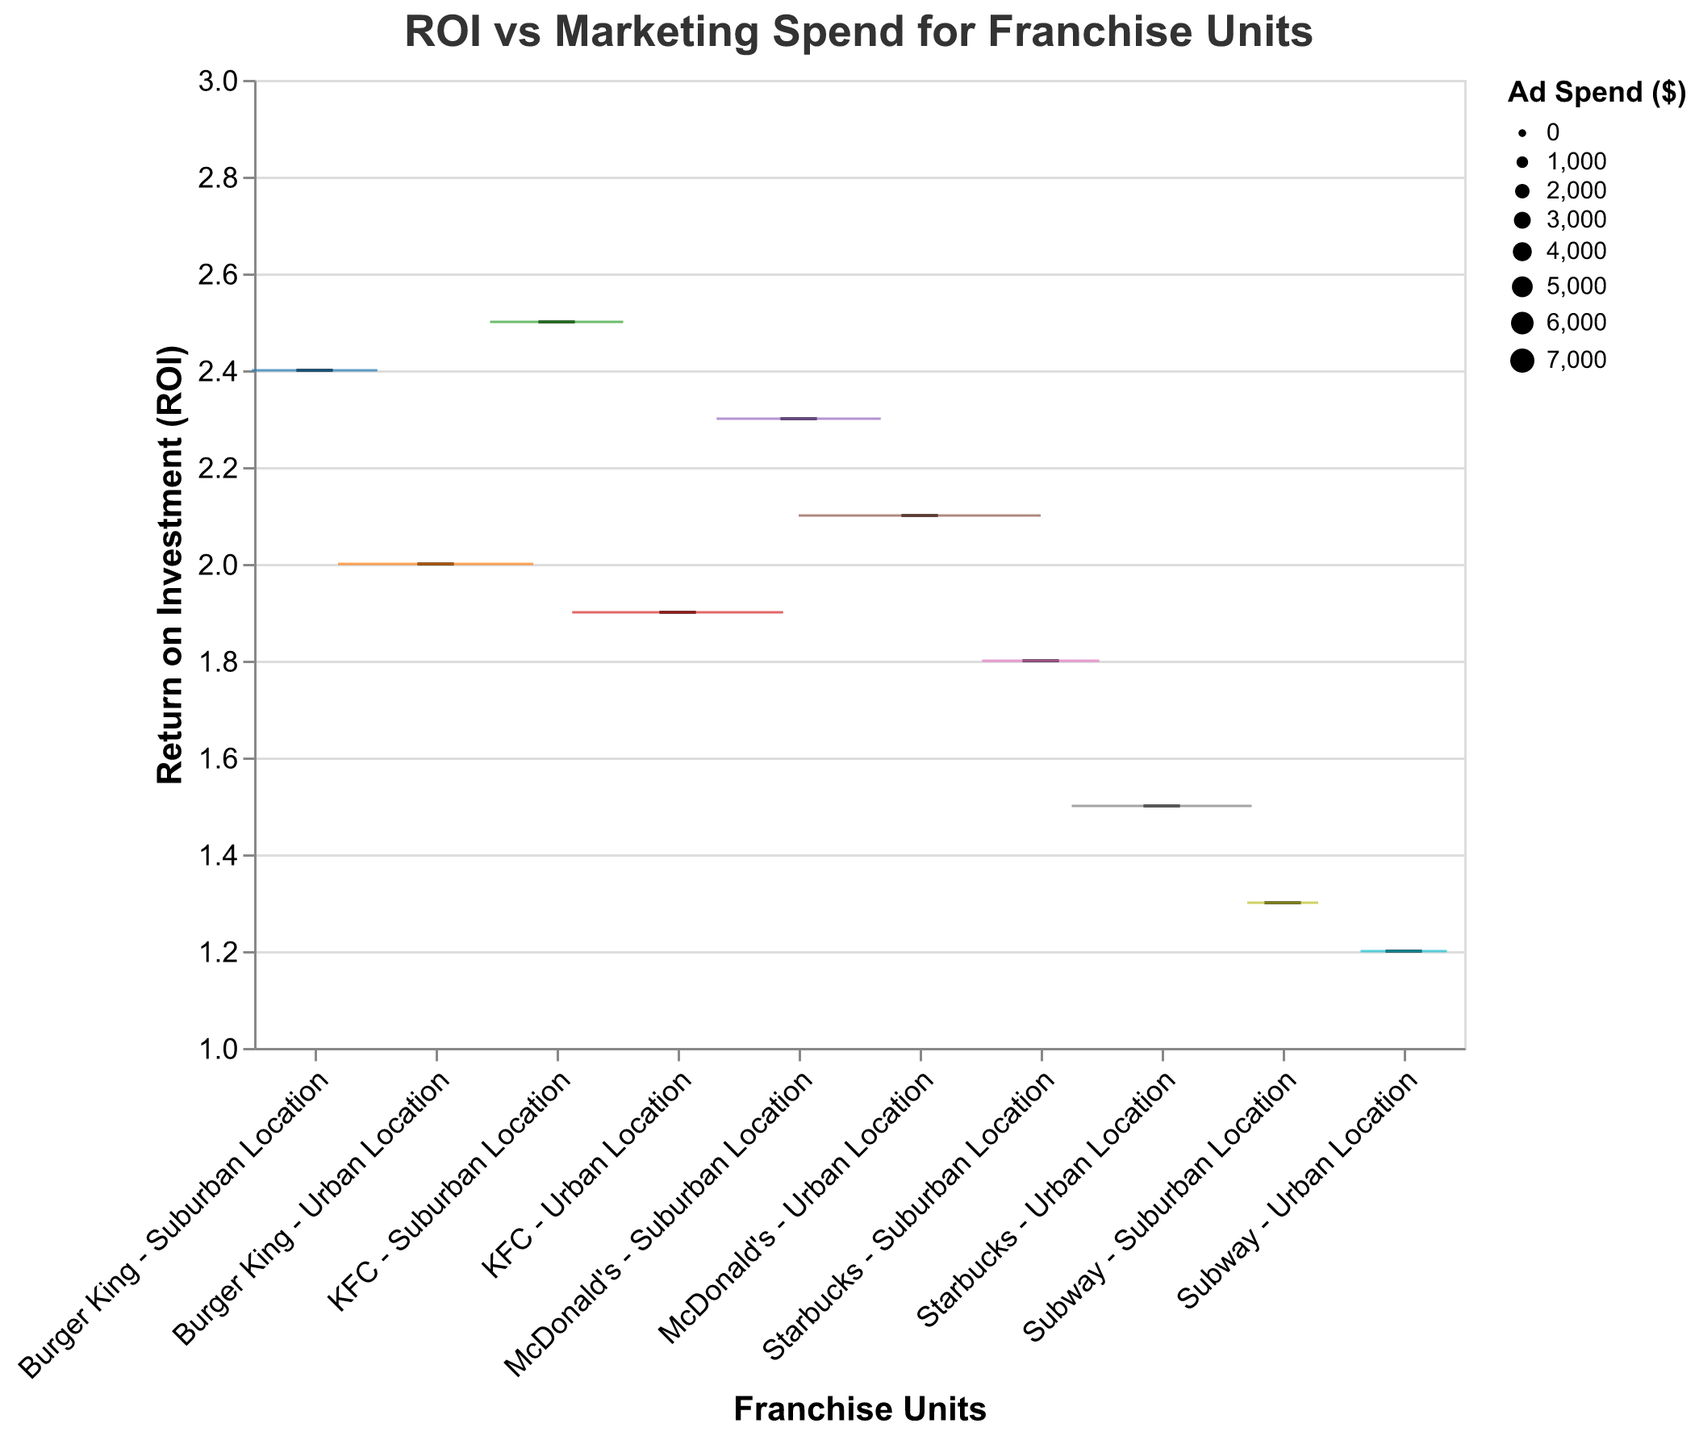What's the title of the plot? The plot's title is found at the top of the figure. By reading this, we see it is "ROI vs Marketing Spend for Franchise Units".
Answer: ROI vs Marketing Spend for Franchise Units Which franchise unit has the highest ROI? By examining the y-axis and noting the position of the box plot tops, we see that "KFC - Suburban Location" has the highest ROI, which is around 2.5.
Answer: KFC - Suburban Location How does the ROI for McDonald's - Urban Location compare to McDonald's - Suburban Location? By comparing the two boxplots for McDonald's, we observe that the ROI for McDonald's - Suburban Location (2.3) is higher than that for McDonald's - Urban Location (2.1).
Answer: McDonald's - Suburban Location has a higher ROI than McDonald's - Urban Location What is the average ROI for the suburban franchise units? To find the average ROI, we first add the ROIs of the suburban franchise units: 1.8 (Starbucks) + 2.3 (McDonald’s) + 1.3 (Subway) + 2.5 (KFC) + 2.4 (Burger King) = 10.3. Then, we divide the total by the number of suburban units: 10.3 / 5 = 2.06.
Answer: 2.06 Which franchise unit has the largest ad spend? By examining the size of the box plots, we see that "McDonald's - Urban Location" has the largest box, indicating the highest ad spend of $7000.
Answer: McDonald's - Urban Location What's the median ROI for all franchise units? To find the median ROI, we list all ROIs and find the middle value: 1.2, 1.3, 1.5, 1.8, 1.9, 2.0, 2.1, 2.3, 2.4, 2.5. The median is the average of the 5th and 6th values, (1.9 + 2.0) / 2 = 1.95.
Answer: 1.95 Does urban location generally have higher or lower ROI compared to suburban locations? By comparing individual urban and suburban pairs, we generally see suburban locations tend to have higher ROI than their urban counterparts.
Answer: Suburban locations generally have higher ROI Which franchise unit has the smallest ad spend and what is its ROI? By looking at the smallest box plots, we identify "Subway - Suburban Location" as the unit with the smallest ad spend ($1500) with an ROI of 1.3.
Answer: Subway - Suburban Location, 1.3 What is the difference in ROI between Subway - Urban Location and KFC - Suburban Location? From the plot, "Subway - Urban Location" has an ROI of 1.2 while "KFC - Suburban Location" has an ROI of 2.5. The difference is 2.5 - 1.2 = 1.3.
Answer: 1.3 